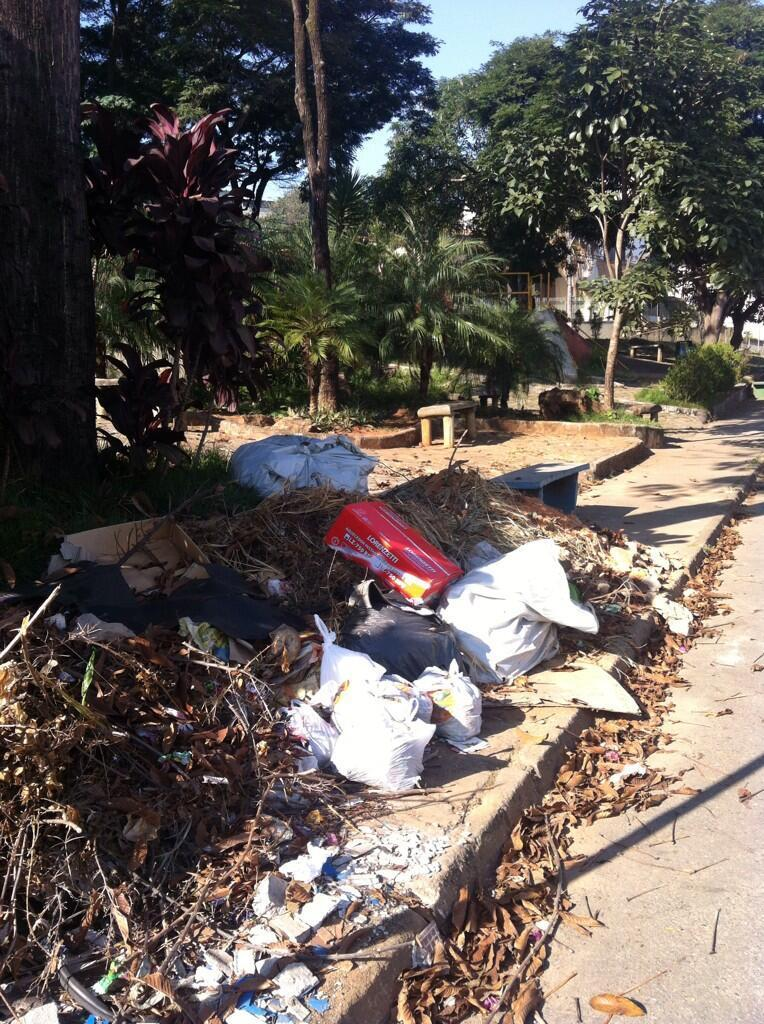What is the main feature of the image? There is a road in the image. What can be seen beside the road? There are leaves, covers, and a box beside the road. What is located above the road? There are trees and a bench above the road. What is visible at the top of the image? The sky is visible at the top of the image. How much income does the faucet generate in the image? There is no faucet present in the image, so it is not possible to determine its income. 